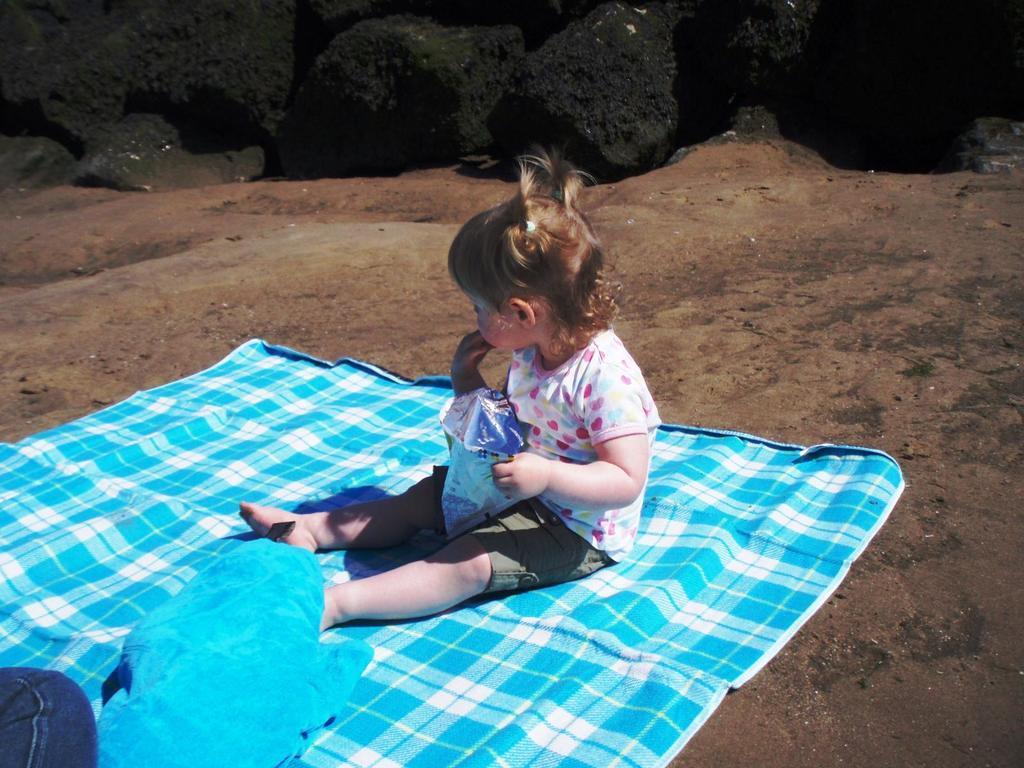How would you summarize this image in a sentence or two? There is one kid sitting on a cloth and holding an object as we can see in the middle of this image. We can see rocks in the background. 